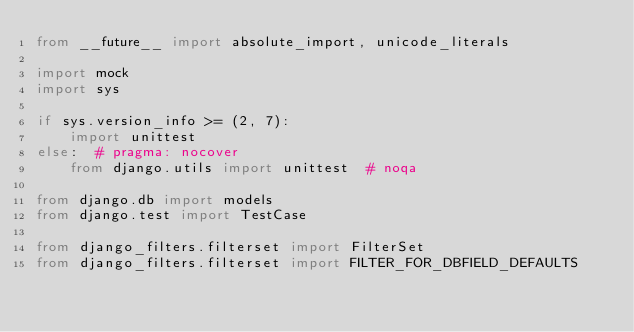Convert code to text. <code><loc_0><loc_0><loc_500><loc_500><_Python_>from __future__ import absolute_import, unicode_literals

import mock
import sys

if sys.version_info >= (2, 7):
    import unittest
else:  # pragma: nocover
    from django.utils import unittest  # noqa

from django.db import models
from django.test import TestCase

from django_filters.filterset import FilterSet
from django_filters.filterset import FILTER_FOR_DBFIELD_DEFAULTS</code> 